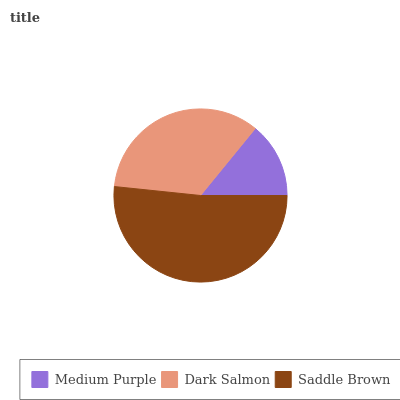Is Medium Purple the minimum?
Answer yes or no. Yes. Is Saddle Brown the maximum?
Answer yes or no. Yes. Is Dark Salmon the minimum?
Answer yes or no. No. Is Dark Salmon the maximum?
Answer yes or no. No. Is Dark Salmon greater than Medium Purple?
Answer yes or no. Yes. Is Medium Purple less than Dark Salmon?
Answer yes or no. Yes. Is Medium Purple greater than Dark Salmon?
Answer yes or no. No. Is Dark Salmon less than Medium Purple?
Answer yes or no. No. Is Dark Salmon the high median?
Answer yes or no. Yes. Is Dark Salmon the low median?
Answer yes or no. Yes. Is Saddle Brown the high median?
Answer yes or no. No. Is Medium Purple the low median?
Answer yes or no. No. 